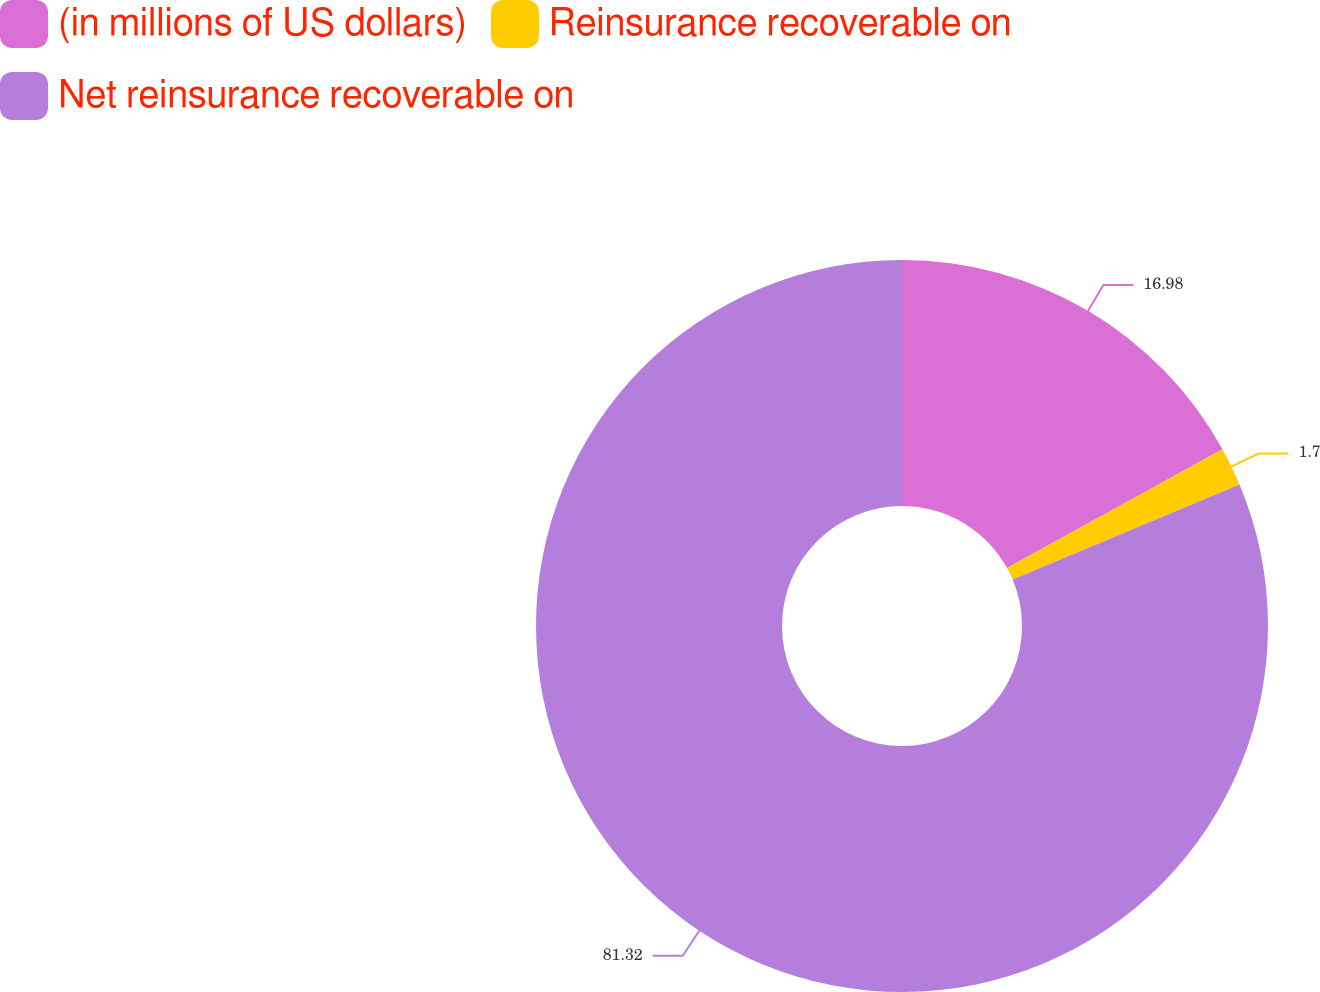Convert chart. <chart><loc_0><loc_0><loc_500><loc_500><pie_chart><fcel>(in millions of US dollars)<fcel>Reinsurance recoverable on<fcel>Net reinsurance recoverable on<nl><fcel>16.98%<fcel>1.7%<fcel>81.32%<nl></chart> 